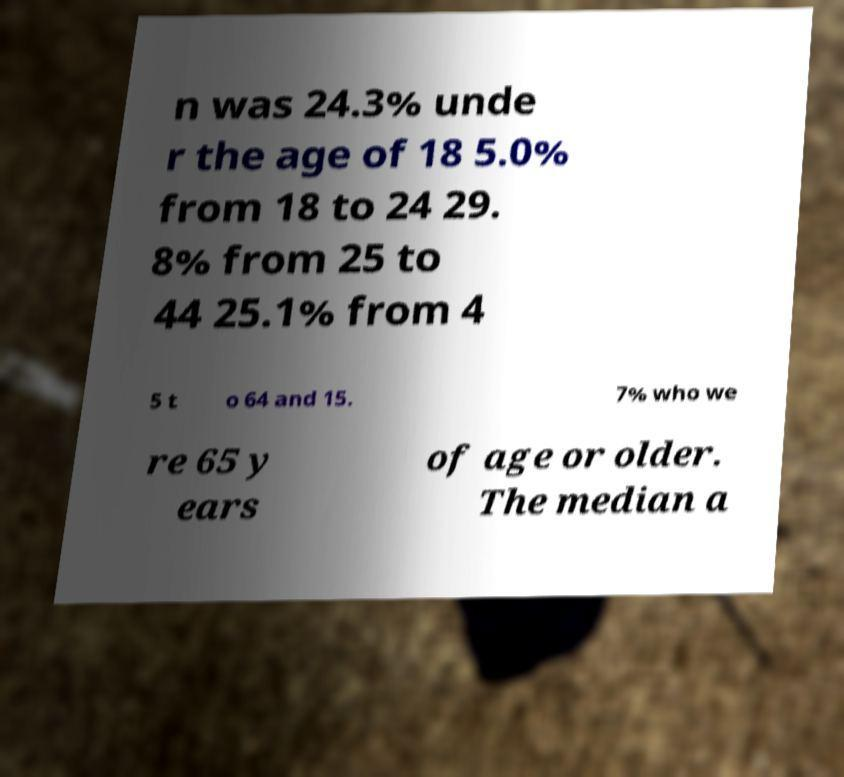Can you read and provide the text displayed in the image?This photo seems to have some interesting text. Can you extract and type it out for me? n was 24.3% unde r the age of 18 5.0% from 18 to 24 29. 8% from 25 to 44 25.1% from 4 5 t o 64 and 15. 7% who we re 65 y ears of age or older. The median a 